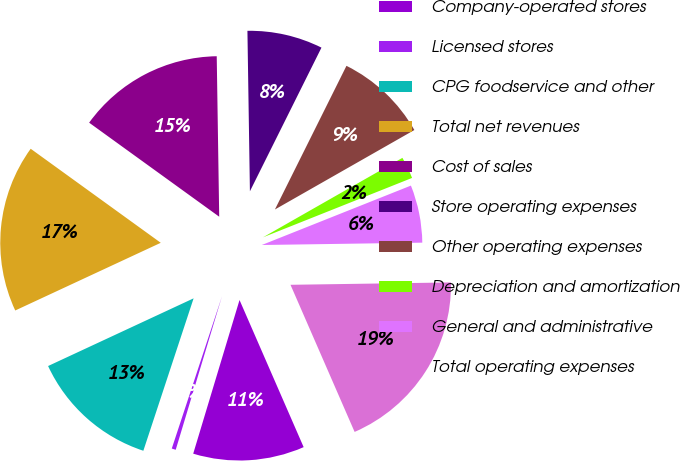Convert chart to OTSL. <chart><loc_0><loc_0><loc_500><loc_500><pie_chart><fcel>Company-operated stores<fcel>Licensed stores<fcel>CPG foodservice and other<fcel>Total net revenues<fcel>Cost of sales<fcel>Store operating expenses<fcel>Other operating expenses<fcel>Depreciation and amortization<fcel>General and administrative<fcel>Total operating expenses<nl><fcel>11.2%<fcel>0.41%<fcel>13.0%<fcel>16.89%<fcel>14.79%<fcel>7.6%<fcel>9.4%<fcel>2.21%<fcel>5.8%<fcel>18.69%<nl></chart> 